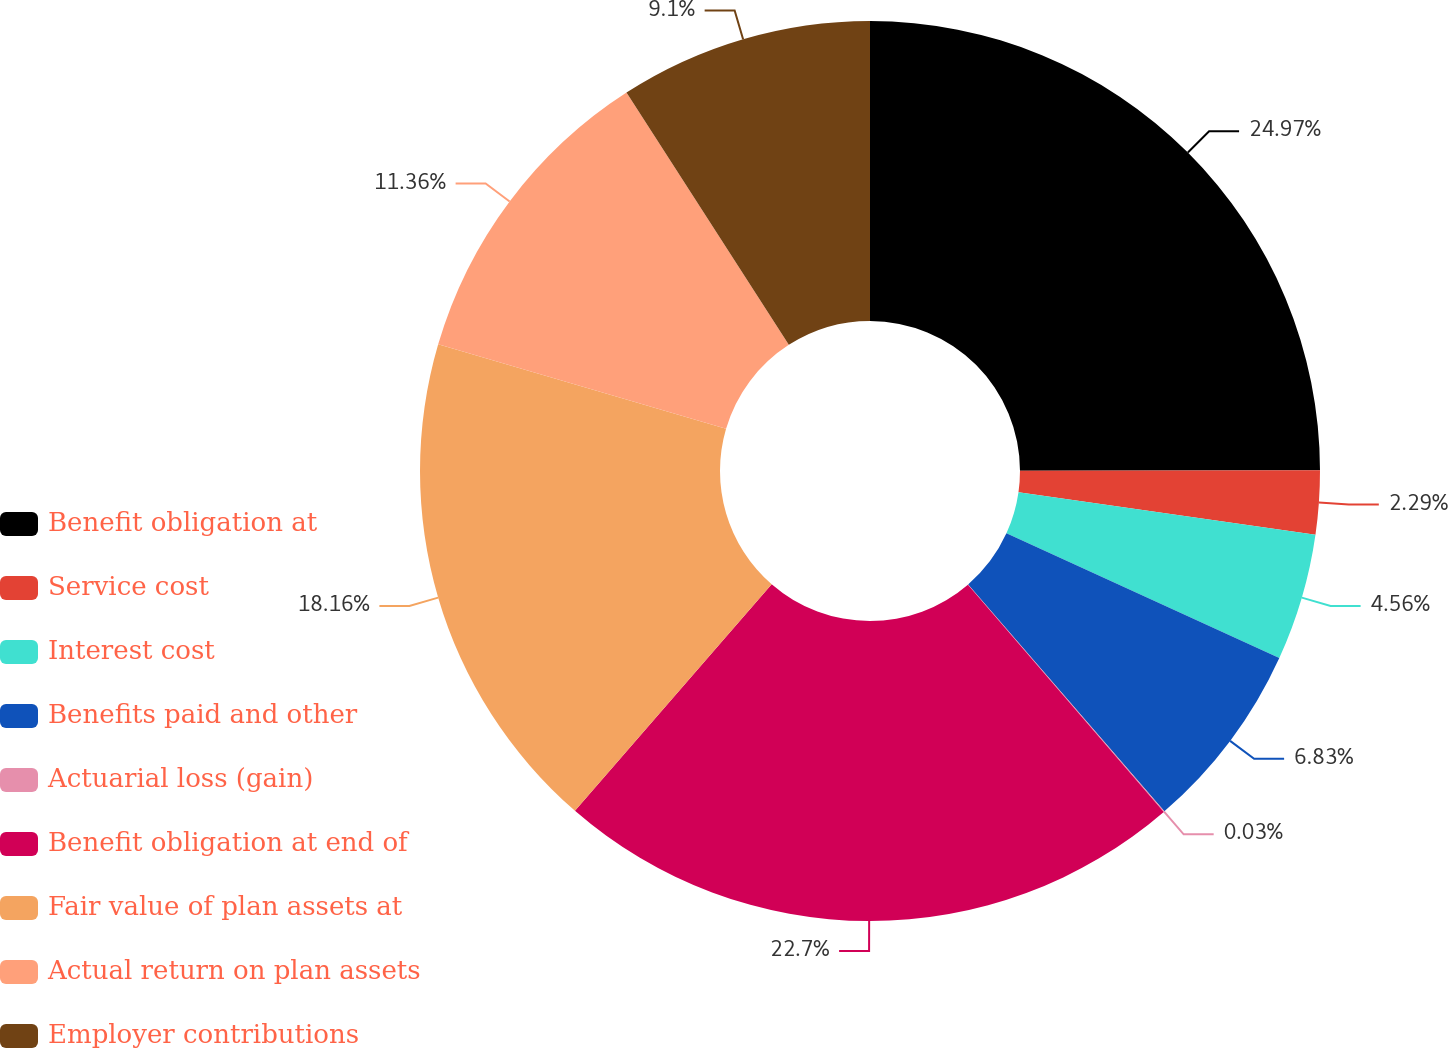Convert chart. <chart><loc_0><loc_0><loc_500><loc_500><pie_chart><fcel>Benefit obligation at<fcel>Service cost<fcel>Interest cost<fcel>Benefits paid and other<fcel>Actuarial loss (gain)<fcel>Benefit obligation at end of<fcel>Fair value of plan assets at<fcel>Actual return on plan assets<fcel>Employer contributions<nl><fcel>24.97%<fcel>2.29%<fcel>4.56%<fcel>6.83%<fcel>0.03%<fcel>22.7%<fcel>18.16%<fcel>11.36%<fcel>9.1%<nl></chart> 